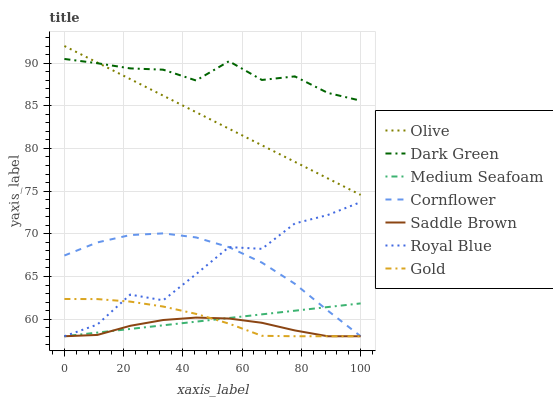Does Saddle Brown have the minimum area under the curve?
Answer yes or no. Yes. Does Dark Green have the maximum area under the curve?
Answer yes or no. Yes. Does Gold have the minimum area under the curve?
Answer yes or no. No. Does Gold have the maximum area under the curve?
Answer yes or no. No. Is Medium Seafoam the smoothest?
Answer yes or no. Yes. Is Royal Blue the roughest?
Answer yes or no. Yes. Is Gold the smoothest?
Answer yes or no. No. Is Gold the roughest?
Answer yes or no. No. Does Cornflower have the lowest value?
Answer yes or no. Yes. Does Olive have the lowest value?
Answer yes or no. No. Does Olive have the highest value?
Answer yes or no. Yes. Does Gold have the highest value?
Answer yes or no. No. Is Medium Seafoam less than Olive?
Answer yes or no. Yes. Is Dark Green greater than Cornflower?
Answer yes or no. Yes. Does Medium Seafoam intersect Royal Blue?
Answer yes or no. Yes. Is Medium Seafoam less than Royal Blue?
Answer yes or no. No. Is Medium Seafoam greater than Royal Blue?
Answer yes or no. No. Does Medium Seafoam intersect Olive?
Answer yes or no. No. 